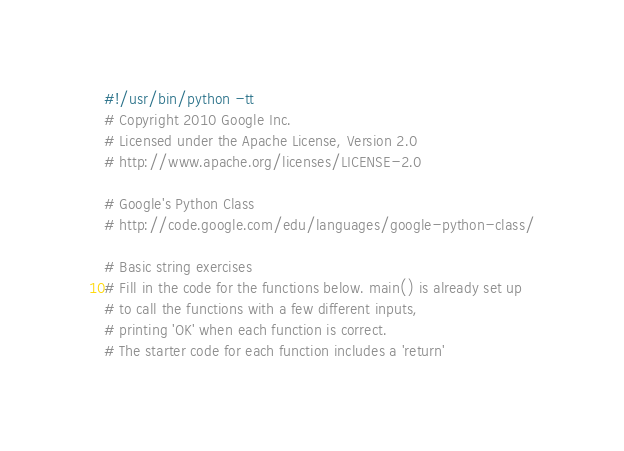<code> <loc_0><loc_0><loc_500><loc_500><_Python_>#!/usr/bin/python -tt
# Copyright 2010 Google Inc.
# Licensed under the Apache License, Version 2.0
# http://www.apache.org/licenses/LICENSE-2.0

# Google's Python Class
# http://code.google.com/edu/languages/google-python-class/

# Basic string exercises
# Fill in the code for the functions below. main() is already set up
# to call the functions with a few different inputs,
# printing 'OK' when each function is correct.
# The starter code for each function includes a 'return'</code> 